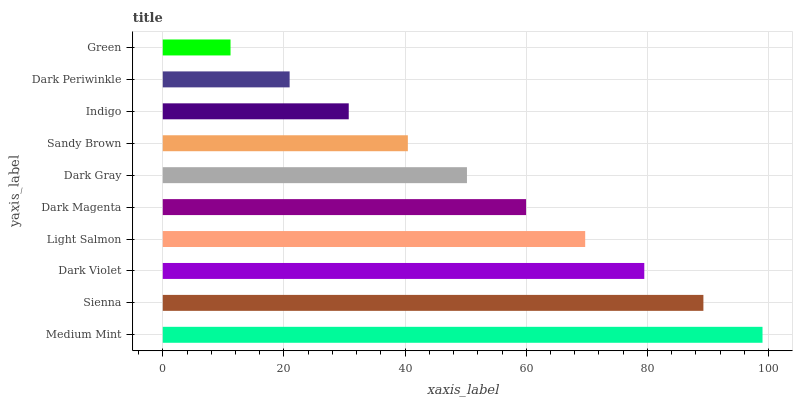Is Green the minimum?
Answer yes or no. Yes. Is Medium Mint the maximum?
Answer yes or no. Yes. Is Sienna the minimum?
Answer yes or no. No. Is Sienna the maximum?
Answer yes or no. No. Is Medium Mint greater than Sienna?
Answer yes or no. Yes. Is Sienna less than Medium Mint?
Answer yes or no. Yes. Is Sienna greater than Medium Mint?
Answer yes or no. No. Is Medium Mint less than Sienna?
Answer yes or no. No. Is Dark Magenta the high median?
Answer yes or no. Yes. Is Dark Gray the low median?
Answer yes or no. Yes. Is Medium Mint the high median?
Answer yes or no. No. Is Dark Magenta the low median?
Answer yes or no. No. 